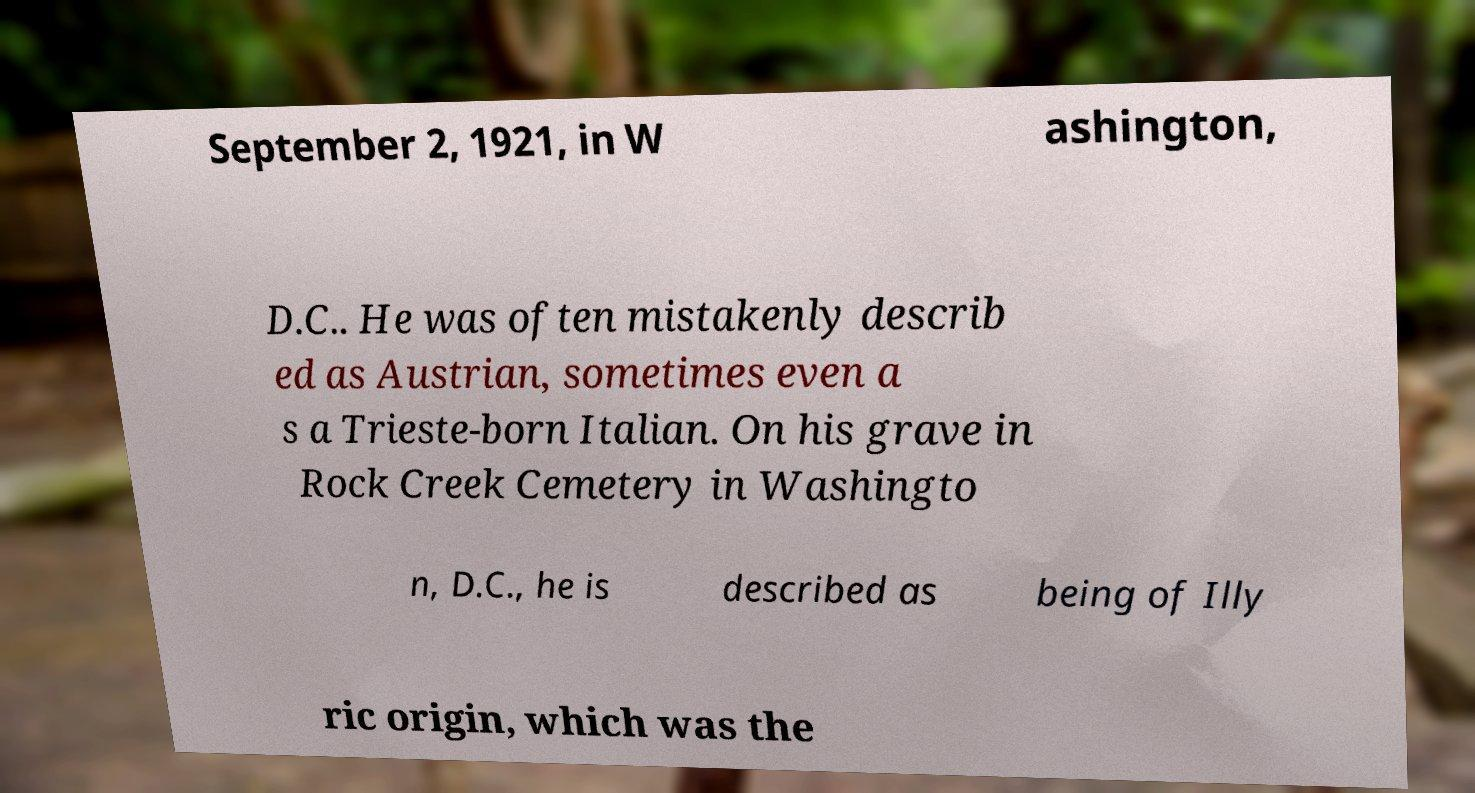Can you read and provide the text displayed in the image?This photo seems to have some interesting text. Can you extract and type it out for me? September 2, 1921, in W ashington, D.C.. He was often mistakenly describ ed as Austrian, sometimes even a s a Trieste-born Italian. On his grave in Rock Creek Cemetery in Washingto n, D.C., he is described as being of Illy ric origin, which was the 